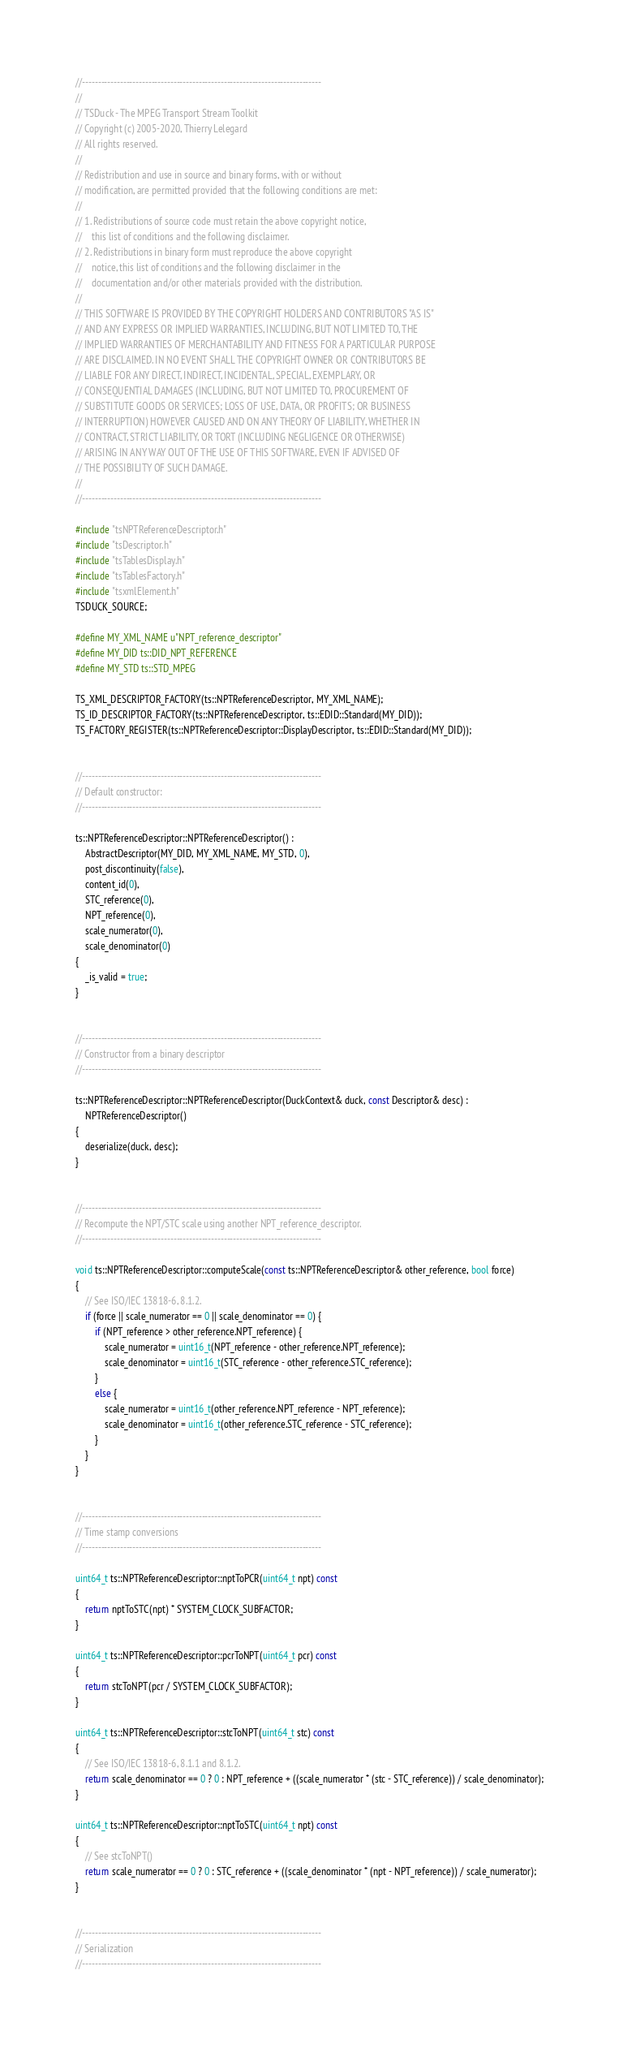Convert code to text. <code><loc_0><loc_0><loc_500><loc_500><_C++_>//----------------------------------------------------------------------------
//
// TSDuck - The MPEG Transport Stream Toolkit
// Copyright (c) 2005-2020, Thierry Lelegard
// All rights reserved.
//
// Redistribution and use in source and binary forms, with or without
// modification, are permitted provided that the following conditions are met:
//
// 1. Redistributions of source code must retain the above copyright notice,
//    this list of conditions and the following disclaimer.
// 2. Redistributions in binary form must reproduce the above copyright
//    notice, this list of conditions and the following disclaimer in the
//    documentation and/or other materials provided with the distribution.
//
// THIS SOFTWARE IS PROVIDED BY THE COPYRIGHT HOLDERS AND CONTRIBUTORS "AS IS"
// AND ANY EXPRESS OR IMPLIED WARRANTIES, INCLUDING, BUT NOT LIMITED TO, THE
// IMPLIED WARRANTIES OF MERCHANTABILITY AND FITNESS FOR A PARTICULAR PURPOSE
// ARE DISCLAIMED. IN NO EVENT SHALL THE COPYRIGHT OWNER OR CONTRIBUTORS BE
// LIABLE FOR ANY DIRECT, INDIRECT, INCIDENTAL, SPECIAL, EXEMPLARY, OR
// CONSEQUENTIAL DAMAGES (INCLUDING, BUT NOT LIMITED TO, PROCUREMENT OF
// SUBSTITUTE GOODS OR SERVICES; LOSS OF USE, DATA, OR PROFITS; OR BUSINESS
// INTERRUPTION) HOWEVER CAUSED AND ON ANY THEORY OF LIABILITY, WHETHER IN
// CONTRACT, STRICT LIABILITY, OR TORT (INCLUDING NEGLIGENCE OR OTHERWISE)
// ARISING IN ANY WAY OUT OF THE USE OF THIS SOFTWARE, EVEN IF ADVISED OF
// THE POSSIBILITY OF SUCH DAMAGE.
//
//----------------------------------------------------------------------------

#include "tsNPTReferenceDescriptor.h"
#include "tsDescriptor.h"
#include "tsTablesDisplay.h"
#include "tsTablesFactory.h"
#include "tsxmlElement.h"
TSDUCK_SOURCE;

#define MY_XML_NAME u"NPT_reference_descriptor"
#define MY_DID ts::DID_NPT_REFERENCE
#define MY_STD ts::STD_MPEG

TS_XML_DESCRIPTOR_FACTORY(ts::NPTReferenceDescriptor, MY_XML_NAME);
TS_ID_DESCRIPTOR_FACTORY(ts::NPTReferenceDescriptor, ts::EDID::Standard(MY_DID));
TS_FACTORY_REGISTER(ts::NPTReferenceDescriptor::DisplayDescriptor, ts::EDID::Standard(MY_DID));


//----------------------------------------------------------------------------
// Default constructor:
//----------------------------------------------------------------------------

ts::NPTReferenceDescriptor::NPTReferenceDescriptor() :
    AbstractDescriptor(MY_DID, MY_XML_NAME, MY_STD, 0),
    post_discontinuity(false),
    content_id(0),
    STC_reference(0),
    NPT_reference(0),
    scale_numerator(0),
    scale_denominator(0)
{
    _is_valid = true;
}


//----------------------------------------------------------------------------
// Constructor from a binary descriptor
//----------------------------------------------------------------------------

ts::NPTReferenceDescriptor::NPTReferenceDescriptor(DuckContext& duck, const Descriptor& desc) :
    NPTReferenceDescriptor()
{
    deserialize(duck, desc);
}


//----------------------------------------------------------------------------
// Recompute the NPT/STC scale using another NPT_reference_descriptor.
//----------------------------------------------------------------------------

void ts::NPTReferenceDescriptor::computeScale(const ts::NPTReferenceDescriptor& other_reference, bool force)
{
    // See ISO/IEC 13818-6, 8.1.2.
    if (force || scale_numerator == 0 || scale_denominator == 0) {
        if (NPT_reference > other_reference.NPT_reference) {
            scale_numerator = uint16_t(NPT_reference - other_reference.NPT_reference);
            scale_denominator = uint16_t(STC_reference - other_reference.STC_reference);
        }
        else {
            scale_numerator = uint16_t(other_reference.NPT_reference - NPT_reference);
            scale_denominator = uint16_t(other_reference.STC_reference - STC_reference);
        }
    }
}


//----------------------------------------------------------------------------
// Time stamp conversions
//----------------------------------------------------------------------------

uint64_t ts::NPTReferenceDescriptor::nptToPCR(uint64_t npt) const
{
    return nptToSTC(npt) * SYSTEM_CLOCK_SUBFACTOR;
}

uint64_t ts::NPTReferenceDescriptor::pcrToNPT(uint64_t pcr) const
{
    return stcToNPT(pcr / SYSTEM_CLOCK_SUBFACTOR);
}

uint64_t ts::NPTReferenceDescriptor::stcToNPT(uint64_t stc) const
{
    // See ISO/IEC 13818-6, 8.1.1 and 8.1.2.
    return scale_denominator == 0 ? 0 : NPT_reference + ((scale_numerator * (stc - STC_reference)) / scale_denominator);
}

uint64_t ts::NPTReferenceDescriptor::nptToSTC(uint64_t npt) const
{
    // See stcToNPT()
    return scale_numerator == 0 ? 0 : STC_reference + ((scale_denominator * (npt - NPT_reference)) / scale_numerator);
}


//----------------------------------------------------------------------------
// Serialization
//----------------------------------------------------------------------------
</code> 